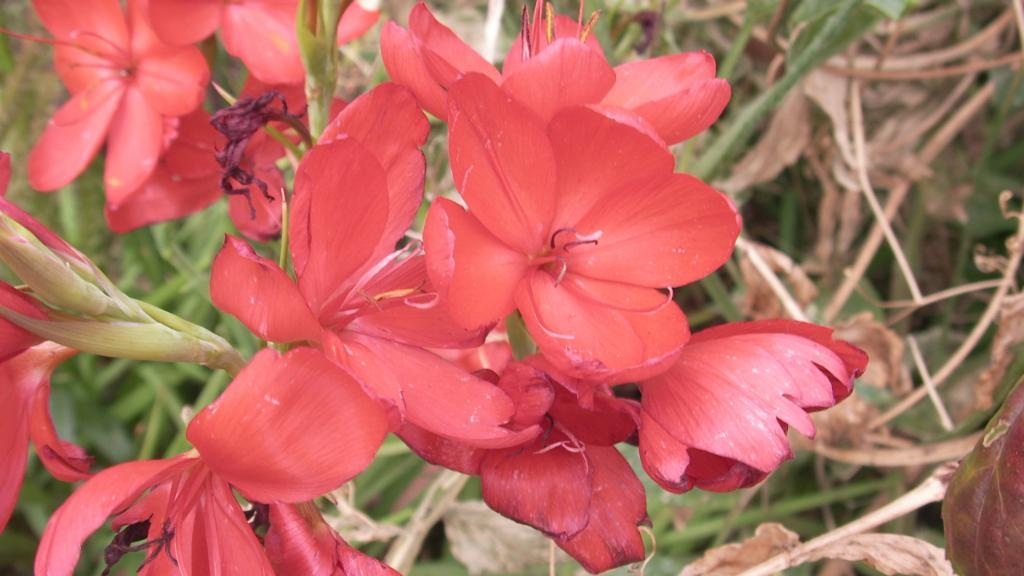What type of flowers can be seen in the image? There are red color flowers in the image. What color are the leaves in the image? There are green color leaves in the image. What is the condition of the plants in the image? There are dry plants in the image. How many cups are being used by the slaves in the image? There are no cups or slaves present in the image. What is the source of shame for the person in the image? There is no person or indication of shame in the image. 